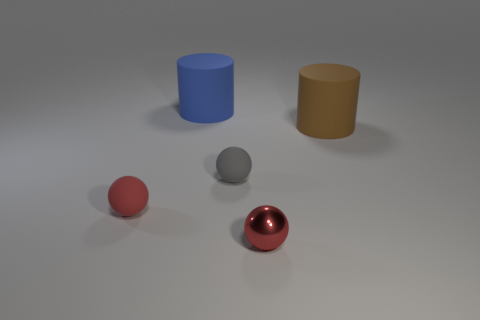There is a ball that is to the right of the red rubber sphere and left of the metal ball; what is its color?
Provide a short and direct response. Gray. How many rubber objects are the same color as the tiny metallic thing?
Your response must be concise. 1. How many cylinders are either red things or tiny red matte things?
Your answer should be very brief. 0. There is a metallic sphere that is the same size as the red matte thing; what color is it?
Ensure brevity in your answer.  Red. Is there a big matte cylinder that is to the left of the tiny red thing that is on the right side of the small object that is behind the red rubber ball?
Your answer should be compact. Yes. What is the size of the gray matte thing?
Your answer should be very brief. Small. How many things are either tiny metallic cylinders or red things?
Give a very brief answer. 2. There is another large thing that is the same material as the big blue thing; what color is it?
Provide a succinct answer. Brown. Is the shape of the large matte thing that is behind the large brown object the same as  the red shiny object?
Your answer should be very brief. No. What number of objects are either red objects that are to the right of the large blue cylinder or small spheres that are behind the red shiny sphere?
Provide a succinct answer. 3. 